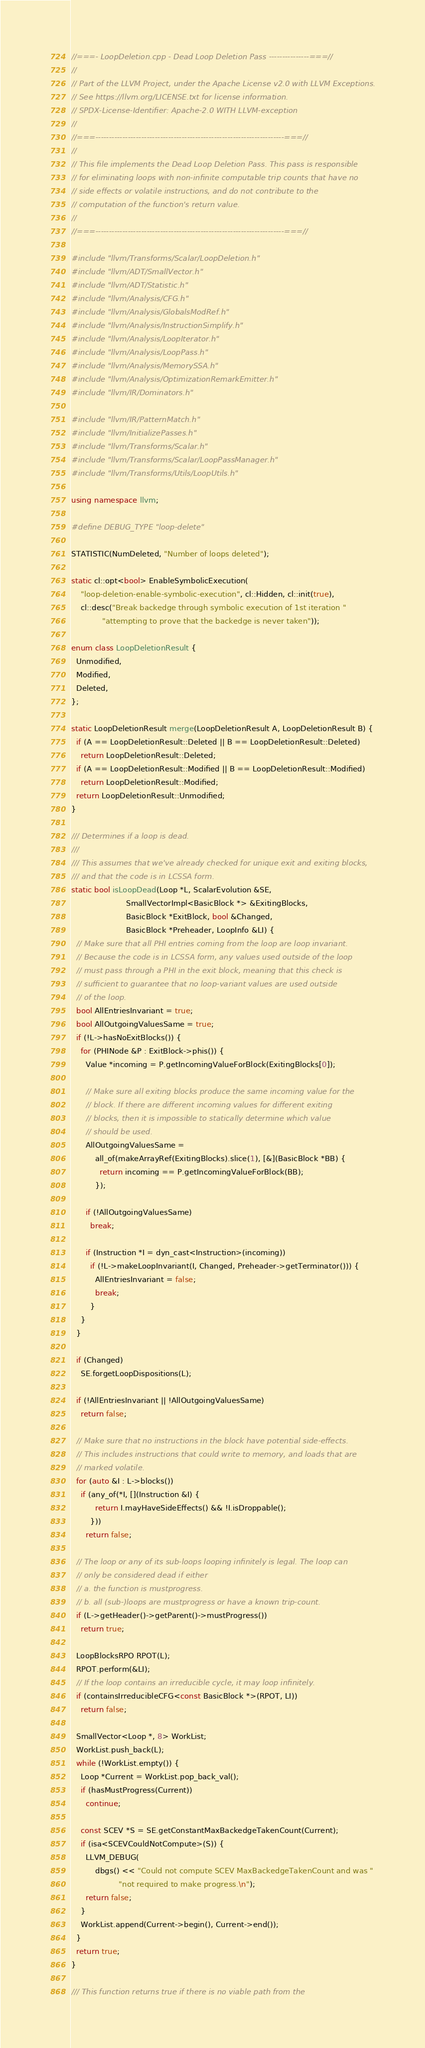Convert code to text. <code><loc_0><loc_0><loc_500><loc_500><_C++_>//===- LoopDeletion.cpp - Dead Loop Deletion Pass ---------------===//
//
// Part of the LLVM Project, under the Apache License v2.0 with LLVM Exceptions.
// See https://llvm.org/LICENSE.txt for license information.
// SPDX-License-Identifier: Apache-2.0 WITH LLVM-exception
//
//===----------------------------------------------------------------------===//
//
// This file implements the Dead Loop Deletion Pass. This pass is responsible
// for eliminating loops with non-infinite computable trip counts that have no
// side effects or volatile instructions, and do not contribute to the
// computation of the function's return value.
//
//===----------------------------------------------------------------------===//

#include "llvm/Transforms/Scalar/LoopDeletion.h"
#include "llvm/ADT/SmallVector.h"
#include "llvm/ADT/Statistic.h"
#include "llvm/Analysis/CFG.h"
#include "llvm/Analysis/GlobalsModRef.h"
#include "llvm/Analysis/InstructionSimplify.h"
#include "llvm/Analysis/LoopIterator.h"
#include "llvm/Analysis/LoopPass.h"
#include "llvm/Analysis/MemorySSA.h"
#include "llvm/Analysis/OptimizationRemarkEmitter.h"
#include "llvm/IR/Dominators.h"

#include "llvm/IR/PatternMatch.h"
#include "llvm/InitializePasses.h"
#include "llvm/Transforms/Scalar.h"
#include "llvm/Transforms/Scalar/LoopPassManager.h"
#include "llvm/Transforms/Utils/LoopUtils.h"

using namespace llvm;

#define DEBUG_TYPE "loop-delete"

STATISTIC(NumDeleted, "Number of loops deleted");

static cl::opt<bool> EnableSymbolicExecution(
    "loop-deletion-enable-symbolic-execution", cl::Hidden, cl::init(true),
    cl::desc("Break backedge through symbolic execution of 1st iteration "
             "attempting to prove that the backedge is never taken"));

enum class LoopDeletionResult {
  Unmodified,
  Modified,
  Deleted,
};

static LoopDeletionResult merge(LoopDeletionResult A, LoopDeletionResult B) {
  if (A == LoopDeletionResult::Deleted || B == LoopDeletionResult::Deleted)
    return LoopDeletionResult::Deleted;
  if (A == LoopDeletionResult::Modified || B == LoopDeletionResult::Modified)
    return LoopDeletionResult::Modified;
  return LoopDeletionResult::Unmodified;
}

/// Determines if a loop is dead.
///
/// This assumes that we've already checked for unique exit and exiting blocks,
/// and that the code is in LCSSA form.
static bool isLoopDead(Loop *L, ScalarEvolution &SE,
                       SmallVectorImpl<BasicBlock *> &ExitingBlocks,
                       BasicBlock *ExitBlock, bool &Changed,
                       BasicBlock *Preheader, LoopInfo &LI) {
  // Make sure that all PHI entries coming from the loop are loop invariant.
  // Because the code is in LCSSA form, any values used outside of the loop
  // must pass through a PHI in the exit block, meaning that this check is
  // sufficient to guarantee that no loop-variant values are used outside
  // of the loop.
  bool AllEntriesInvariant = true;
  bool AllOutgoingValuesSame = true;
  if (!L->hasNoExitBlocks()) {
    for (PHINode &P : ExitBlock->phis()) {
      Value *incoming = P.getIncomingValueForBlock(ExitingBlocks[0]);

      // Make sure all exiting blocks produce the same incoming value for the
      // block. If there are different incoming values for different exiting
      // blocks, then it is impossible to statically determine which value
      // should be used.
      AllOutgoingValuesSame =
          all_of(makeArrayRef(ExitingBlocks).slice(1), [&](BasicBlock *BB) {
            return incoming == P.getIncomingValueForBlock(BB);
          });

      if (!AllOutgoingValuesSame)
        break;

      if (Instruction *I = dyn_cast<Instruction>(incoming))
        if (!L->makeLoopInvariant(I, Changed, Preheader->getTerminator())) {
          AllEntriesInvariant = false;
          break;
        }
    }
  }

  if (Changed)
    SE.forgetLoopDispositions(L);

  if (!AllEntriesInvariant || !AllOutgoingValuesSame)
    return false;

  // Make sure that no instructions in the block have potential side-effects.
  // This includes instructions that could write to memory, and loads that are
  // marked volatile.
  for (auto &I : L->blocks())
    if (any_of(*I, [](Instruction &I) {
          return I.mayHaveSideEffects() && !I.isDroppable();
        }))
      return false;

  // The loop or any of its sub-loops looping infinitely is legal. The loop can
  // only be considered dead if either
  // a. the function is mustprogress.
  // b. all (sub-)loops are mustprogress or have a known trip-count.
  if (L->getHeader()->getParent()->mustProgress())
    return true;

  LoopBlocksRPO RPOT(L);
  RPOT.perform(&LI);
  // If the loop contains an irreducible cycle, it may loop infinitely.
  if (containsIrreducibleCFG<const BasicBlock *>(RPOT, LI))
    return false;

  SmallVector<Loop *, 8> WorkList;
  WorkList.push_back(L);
  while (!WorkList.empty()) {
    Loop *Current = WorkList.pop_back_val();
    if (hasMustProgress(Current))
      continue;

    const SCEV *S = SE.getConstantMaxBackedgeTakenCount(Current);
    if (isa<SCEVCouldNotCompute>(S)) {
      LLVM_DEBUG(
          dbgs() << "Could not compute SCEV MaxBackedgeTakenCount and was "
                    "not required to make progress.\n");
      return false;
    }
    WorkList.append(Current->begin(), Current->end());
  }
  return true;
}

/// This function returns true if there is no viable path from the</code> 